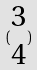<formula> <loc_0><loc_0><loc_500><loc_500>( \begin{matrix} 3 \\ 4 \end{matrix} )</formula> 